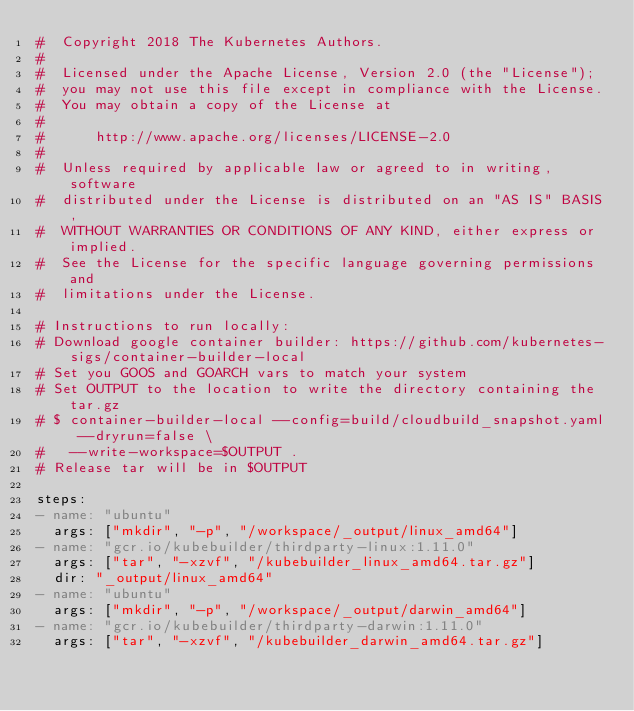Convert code to text. <code><loc_0><loc_0><loc_500><loc_500><_YAML_>#  Copyright 2018 The Kubernetes Authors.
#
#  Licensed under the Apache License, Version 2.0 (the "License");
#  you may not use this file except in compliance with the License.
#  You may obtain a copy of the License at
#
#      http://www.apache.org/licenses/LICENSE-2.0
#
#  Unless required by applicable law or agreed to in writing, software
#  distributed under the License is distributed on an "AS IS" BASIS,
#  WITHOUT WARRANTIES OR CONDITIONS OF ANY KIND, either express or implied.
#  See the License for the specific language governing permissions and
#  limitations under the License.

# Instructions to run locally:
# Download google container builder: https://github.com/kubernetes-sigs/container-builder-local
# Set you GOOS and GOARCH vars to match your system
# Set OUTPUT to the location to write the directory containing the tar.gz
# $ container-builder-local --config=build/cloudbuild_snapshot.yaml --dryrun=false \
#   --write-workspace=$OUTPUT .
# Release tar will be in $OUTPUT

steps:
- name: "ubuntu"
  args: ["mkdir", "-p", "/workspace/_output/linux_amd64"]
- name: "gcr.io/kubebuilder/thirdparty-linux:1.11.0"
  args: ["tar", "-xzvf", "/kubebuilder_linux_amd64.tar.gz"]
  dir: "_output/linux_amd64"
- name: "ubuntu"
  args: ["mkdir", "-p", "/workspace/_output/darwin_amd64"]
- name: "gcr.io/kubebuilder/thirdparty-darwin:1.11.0"
  args: ["tar", "-xzvf", "/kubebuilder_darwin_amd64.tar.gz"]</code> 